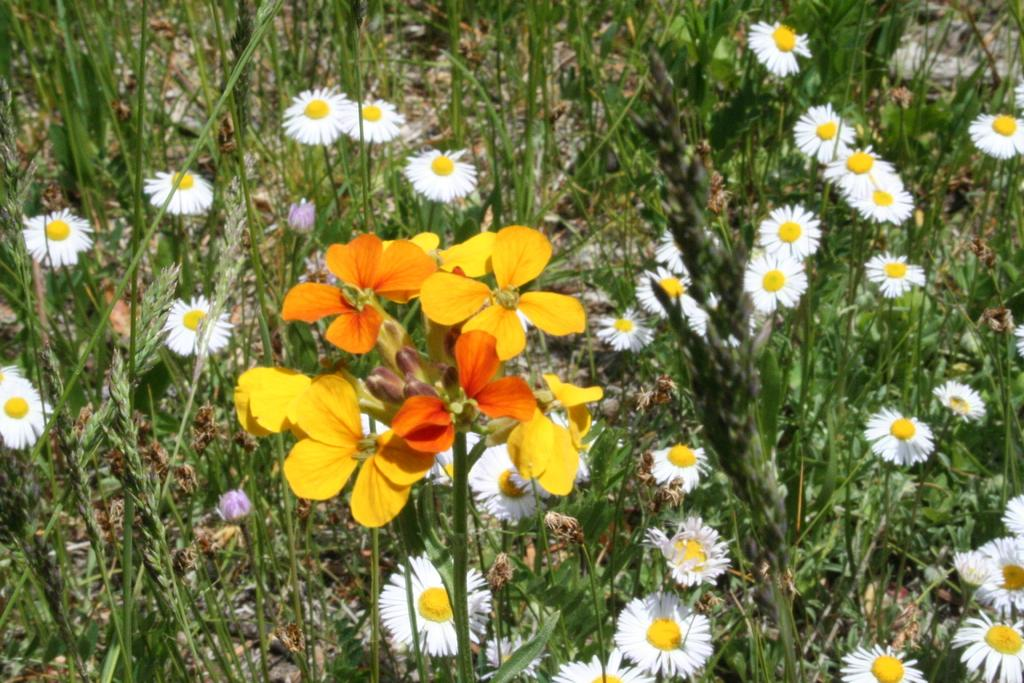What type of living organisms can be seen in the image? There are flowers and plants in the image. Can you describe the plants in the image? The plants in the image are not specified, but they are present alongside the flowers. What type of lamp can be seen in the image? There is no lamp present in the image; it only features flowers and plants. What is the aftermath of the event depicted in the image? There is no event depicted in the image, as it only shows flowers and plants. 